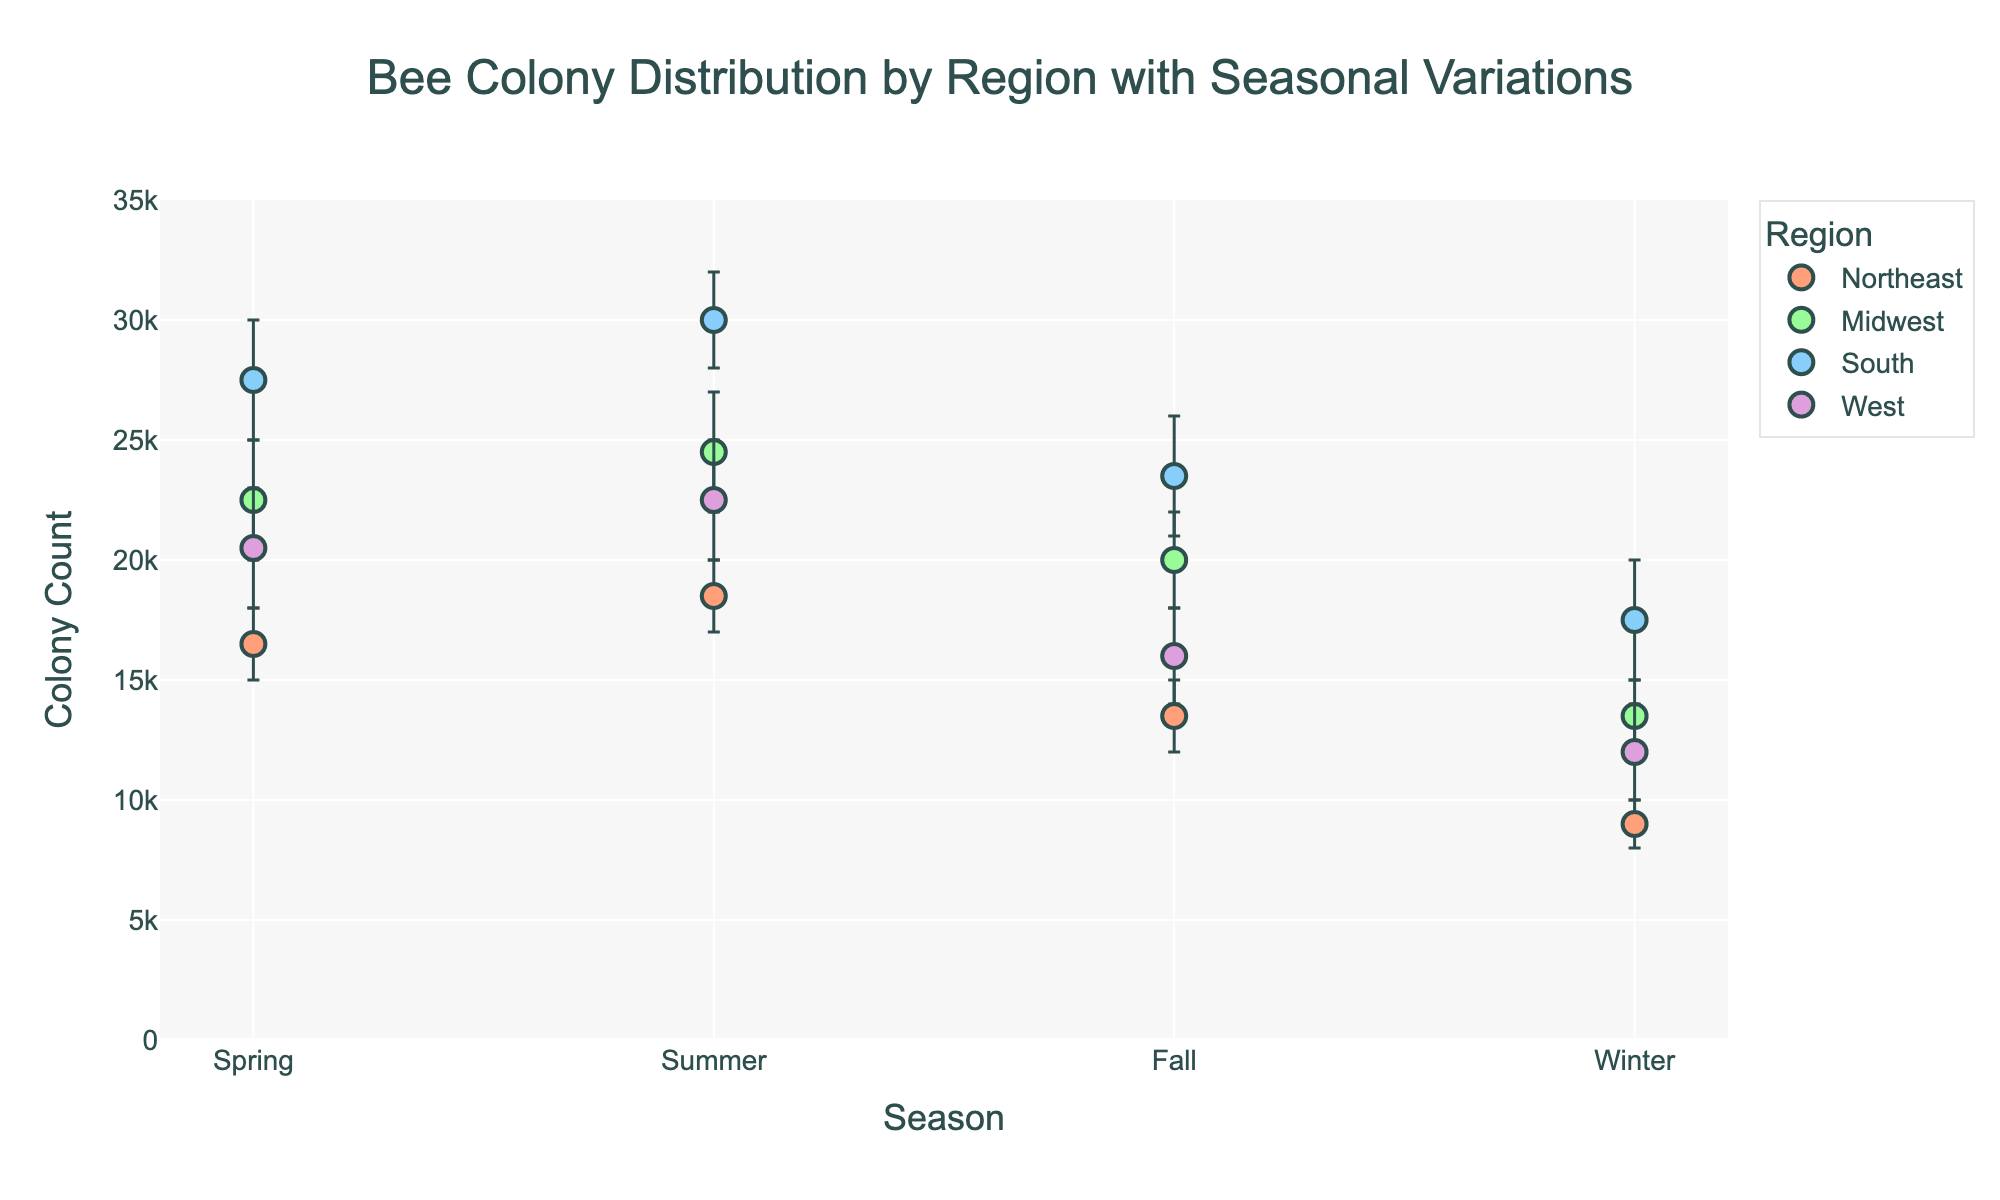Which region has the highest colony count in summer? According to the plot, the South region has the highest colony count during summer, ranging from 28,000 to 32,000.
Answer: South What is the title of the plot? The title is displayed at the top center of the plot and reads "Bee Colony Distribution by Region with Seasonal Variations".
Answer: Bee Colony Distribution by Region with Seasonal Variations How does the colony count vary between spring and winter in the Northeast region? In spring, the colony count in the Northeast region ranges from 15,000 to 18,000. In winter, it ranges from 8,000 to 10,000. So, it decreases by comparing the min and max values of these seasons.
Answer: Decreases Which season shows the smallest range of colony counts in the Midwest region? To find this, look at the error bars for each season in the Midwest region. The winter season shows a range of 12,000 to 15,000, which is a difference of 3,000, the smallest among the seasons.
Answer: Winter What is the average colony count in the West region during fall? The fall colony count in the West region ranges from 14,000 to 18,000. The average is calculated as (14,000 + 18,000) / 2 = 16,000.
Answer: 16,000 Which region shows the most significant decline in colony count from summer to winter? By comparing the ranges for summer and winter for all regions, the South region sees a decline from 28,000-32,000 (summer) to 15,000-20,000 (winter), which is the most significant.
Answer: South What is the range of colony counts in the Midwest region during spring? The range of colony counts in the Midwest during spring is from 20,000 to 25,000.
Answer: 20,000 to 25,000 Do any regions have higher colony counts in winter compared to fall? No regions show higher colony counts in winter compared to fall. All regions exhibit lower colony counts in winter than in fall.
Answer: No What is the difference between the minimum and maximum colony count in the South during spring? In spring, the minimum colony count for the South is 25,000, and the maximum is 30,000. The difference is 30,000 - 25,000 = 5,000.
Answer: 5,000 